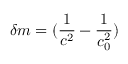<formula> <loc_0><loc_0><loc_500><loc_500>\delta m = ( \frac { 1 } { c ^ { 2 } } - \frac { 1 } { c _ { 0 } ^ { 2 } } )</formula> 